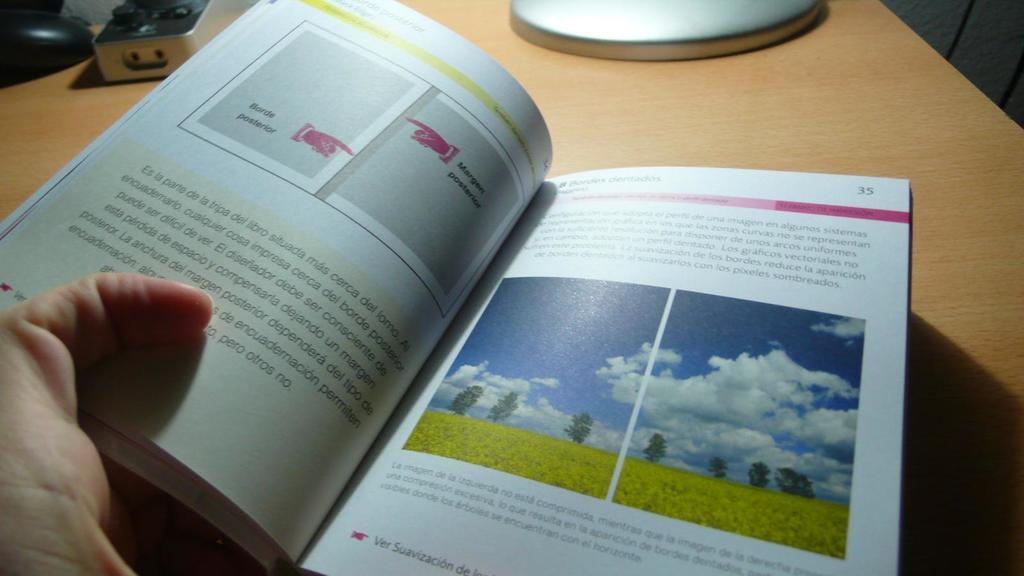What page number is the page on the right?
Provide a succinct answer. 35. 